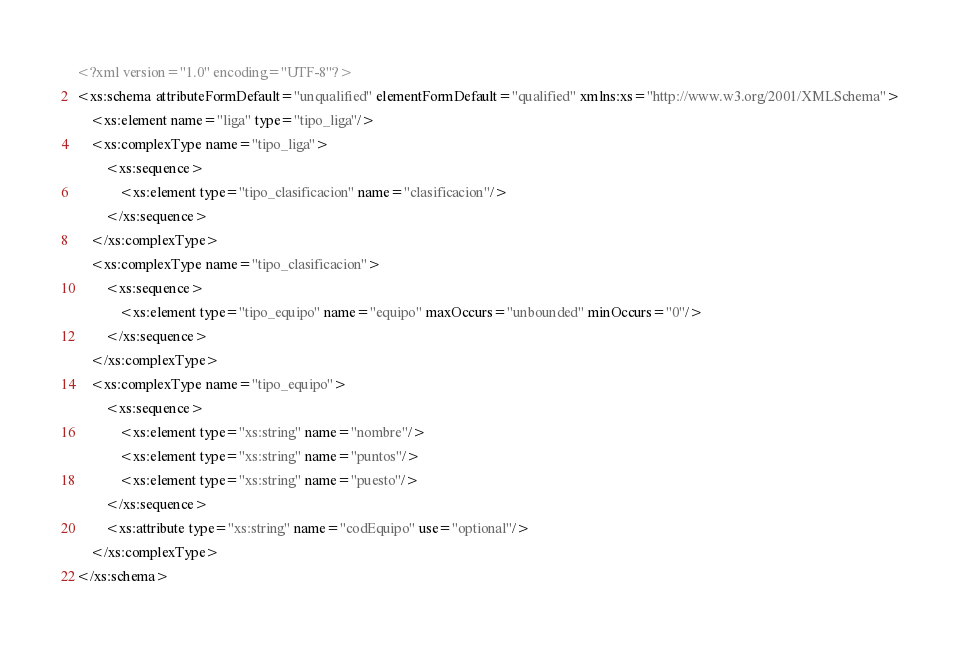Convert code to text. <code><loc_0><loc_0><loc_500><loc_500><_XML_><?xml version="1.0" encoding="UTF-8"?>
<xs:schema attributeFormDefault="unqualified" elementFormDefault="qualified" xmlns:xs="http://www.w3.org/2001/XMLSchema">
    <xs:element name="liga" type="tipo_liga"/>
    <xs:complexType name="tipo_liga">
        <xs:sequence>
            <xs:element type="tipo_clasificacion" name="clasificacion"/>
        </xs:sequence>
    </xs:complexType>
    <xs:complexType name="tipo_clasificacion">
        <xs:sequence>
            <xs:element type="tipo_equipo" name="equipo" maxOccurs="unbounded" minOccurs="0"/>
        </xs:sequence>
    </xs:complexType>
    <xs:complexType name="tipo_equipo">
        <xs:sequence>
            <xs:element type="xs:string" name="nombre"/>
            <xs:element type="xs:string" name="puntos"/>
            <xs:element type="xs:string" name="puesto"/>
        </xs:sequence>
        <xs:attribute type="xs:string" name="codEquipo" use="optional"/>
    </xs:complexType>
</xs:schema></code> 